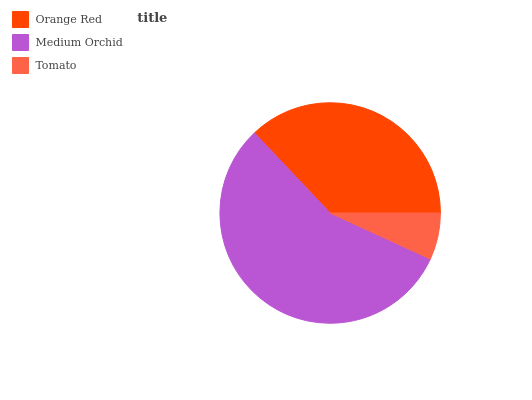Is Tomato the minimum?
Answer yes or no. Yes. Is Medium Orchid the maximum?
Answer yes or no. Yes. Is Medium Orchid the minimum?
Answer yes or no. No. Is Tomato the maximum?
Answer yes or no. No. Is Medium Orchid greater than Tomato?
Answer yes or no. Yes. Is Tomato less than Medium Orchid?
Answer yes or no. Yes. Is Tomato greater than Medium Orchid?
Answer yes or no. No. Is Medium Orchid less than Tomato?
Answer yes or no. No. Is Orange Red the high median?
Answer yes or no. Yes. Is Orange Red the low median?
Answer yes or no. Yes. Is Tomato the high median?
Answer yes or no. No. Is Medium Orchid the low median?
Answer yes or no. No. 